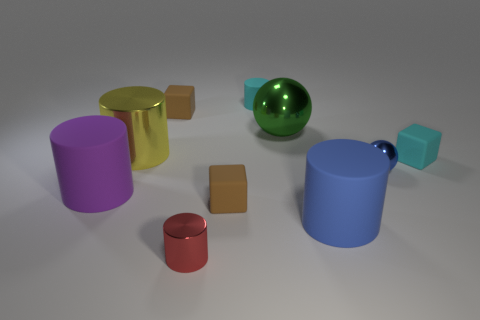There is a rubber cylinder that is on the right side of the green sphere; how big is it?
Your answer should be compact. Large. How many large blue things have the same material as the tiny blue ball?
Offer a very short reply. 0. Does the cyan matte thing behind the yellow object have the same shape as the green object?
Provide a short and direct response. No. The blue object that is in front of the blue metal thing has what shape?
Give a very brief answer. Cylinder. What is the size of the matte object that is the same color as the tiny shiny ball?
Offer a very short reply. Large. What material is the small sphere?
Ensure brevity in your answer.  Metal. What color is the metal ball that is the same size as the red cylinder?
Provide a succinct answer. Blue. What shape is the tiny matte object that is the same color as the tiny matte cylinder?
Make the answer very short. Cube. Does the red object have the same shape as the big blue matte object?
Make the answer very short. Yes. There is a cylinder that is both in front of the large sphere and behind the small cyan rubber block; what material is it made of?
Keep it short and to the point. Metal. 